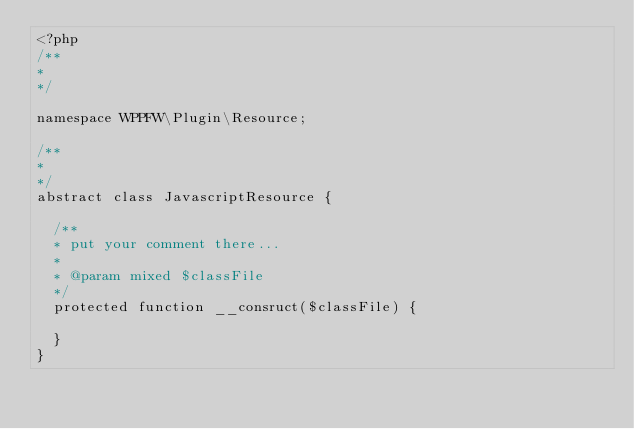<code> <loc_0><loc_0><loc_500><loc_500><_PHP_><?php
/**
* 
*/

namespace WPPFW\Plugin\Resource;

/**
* 
*/
abstract class JavascriptResource {
	
	/**
	* put your comment there...
	* 
	* @param mixed $classFile
	*/
	protected function __consruct($classFile) {
		
	}
}</code> 